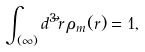Convert formula to latex. <formula><loc_0><loc_0><loc_500><loc_500>\int _ { ( \infty ) } d ^ { 3 } \vec { r } \, \rho _ { m } ( r ) = 1 ,</formula> 